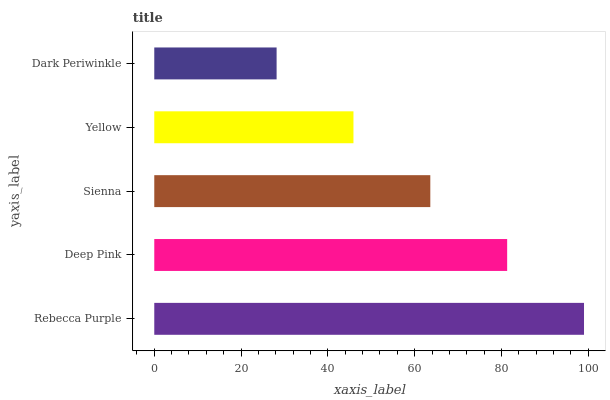Is Dark Periwinkle the minimum?
Answer yes or no. Yes. Is Rebecca Purple the maximum?
Answer yes or no. Yes. Is Deep Pink the minimum?
Answer yes or no. No. Is Deep Pink the maximum?
Answer yes or no. No. Is Rebecca Purple greater than Deep Pink?
Answer yes or no. Yes. Is Deep Pink less than Rebecca Purple?
Answer yes or no. Yes. Is Deep Pink greater than Rebecca Purple?
Answer yes or no. No. Is Rebecca Purple less than Deep Pink?
Answer yes or no. No. Is Sienna the high median?
Answer yes or no. Yes. Is Sienna the low median?
Answer yes or no. Yes. Is Yellow the high median?
Answer yes or no. No. Is Deep Pink the low median?
Answer yes or no. No. 